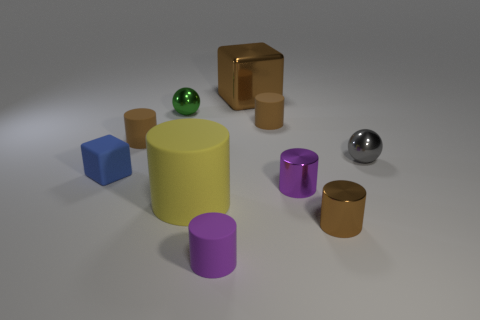Subtract all brown cylinders. How many were subtracted if there are1brown cylinders left? 2 Subtract all yellow balls. How many brown cylinders are left? 3 Subtract all tiny brown metallic cylinders. How many cylinders are left? 5 Subtract all purple cylinders. How many cylinders are left? 4 Subtract all yellow cylinders. Subtract all red blocks. How many cylinders are left? 5 Subtract all cylinders. How many objects are left? 4 Subtract all tiny metallic balls. Subtract all blue things. How many objects are left? 7 Add 1 gray metal spheres. How many gray metal spheres are left? 2 Add 9 blue objects. How many blue objects exist? 10 Subtract 0 brown spheres. How many objects are left? 10 